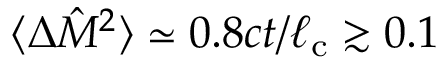<formula> <loc_0><loc_0><loc_500><loc_500>\langle \Delta \hat { M } ^ { 2 } \rangle \simeq 0 . 8 c t / \ell _ { c } \gtrsim 0 . 1</formula> 